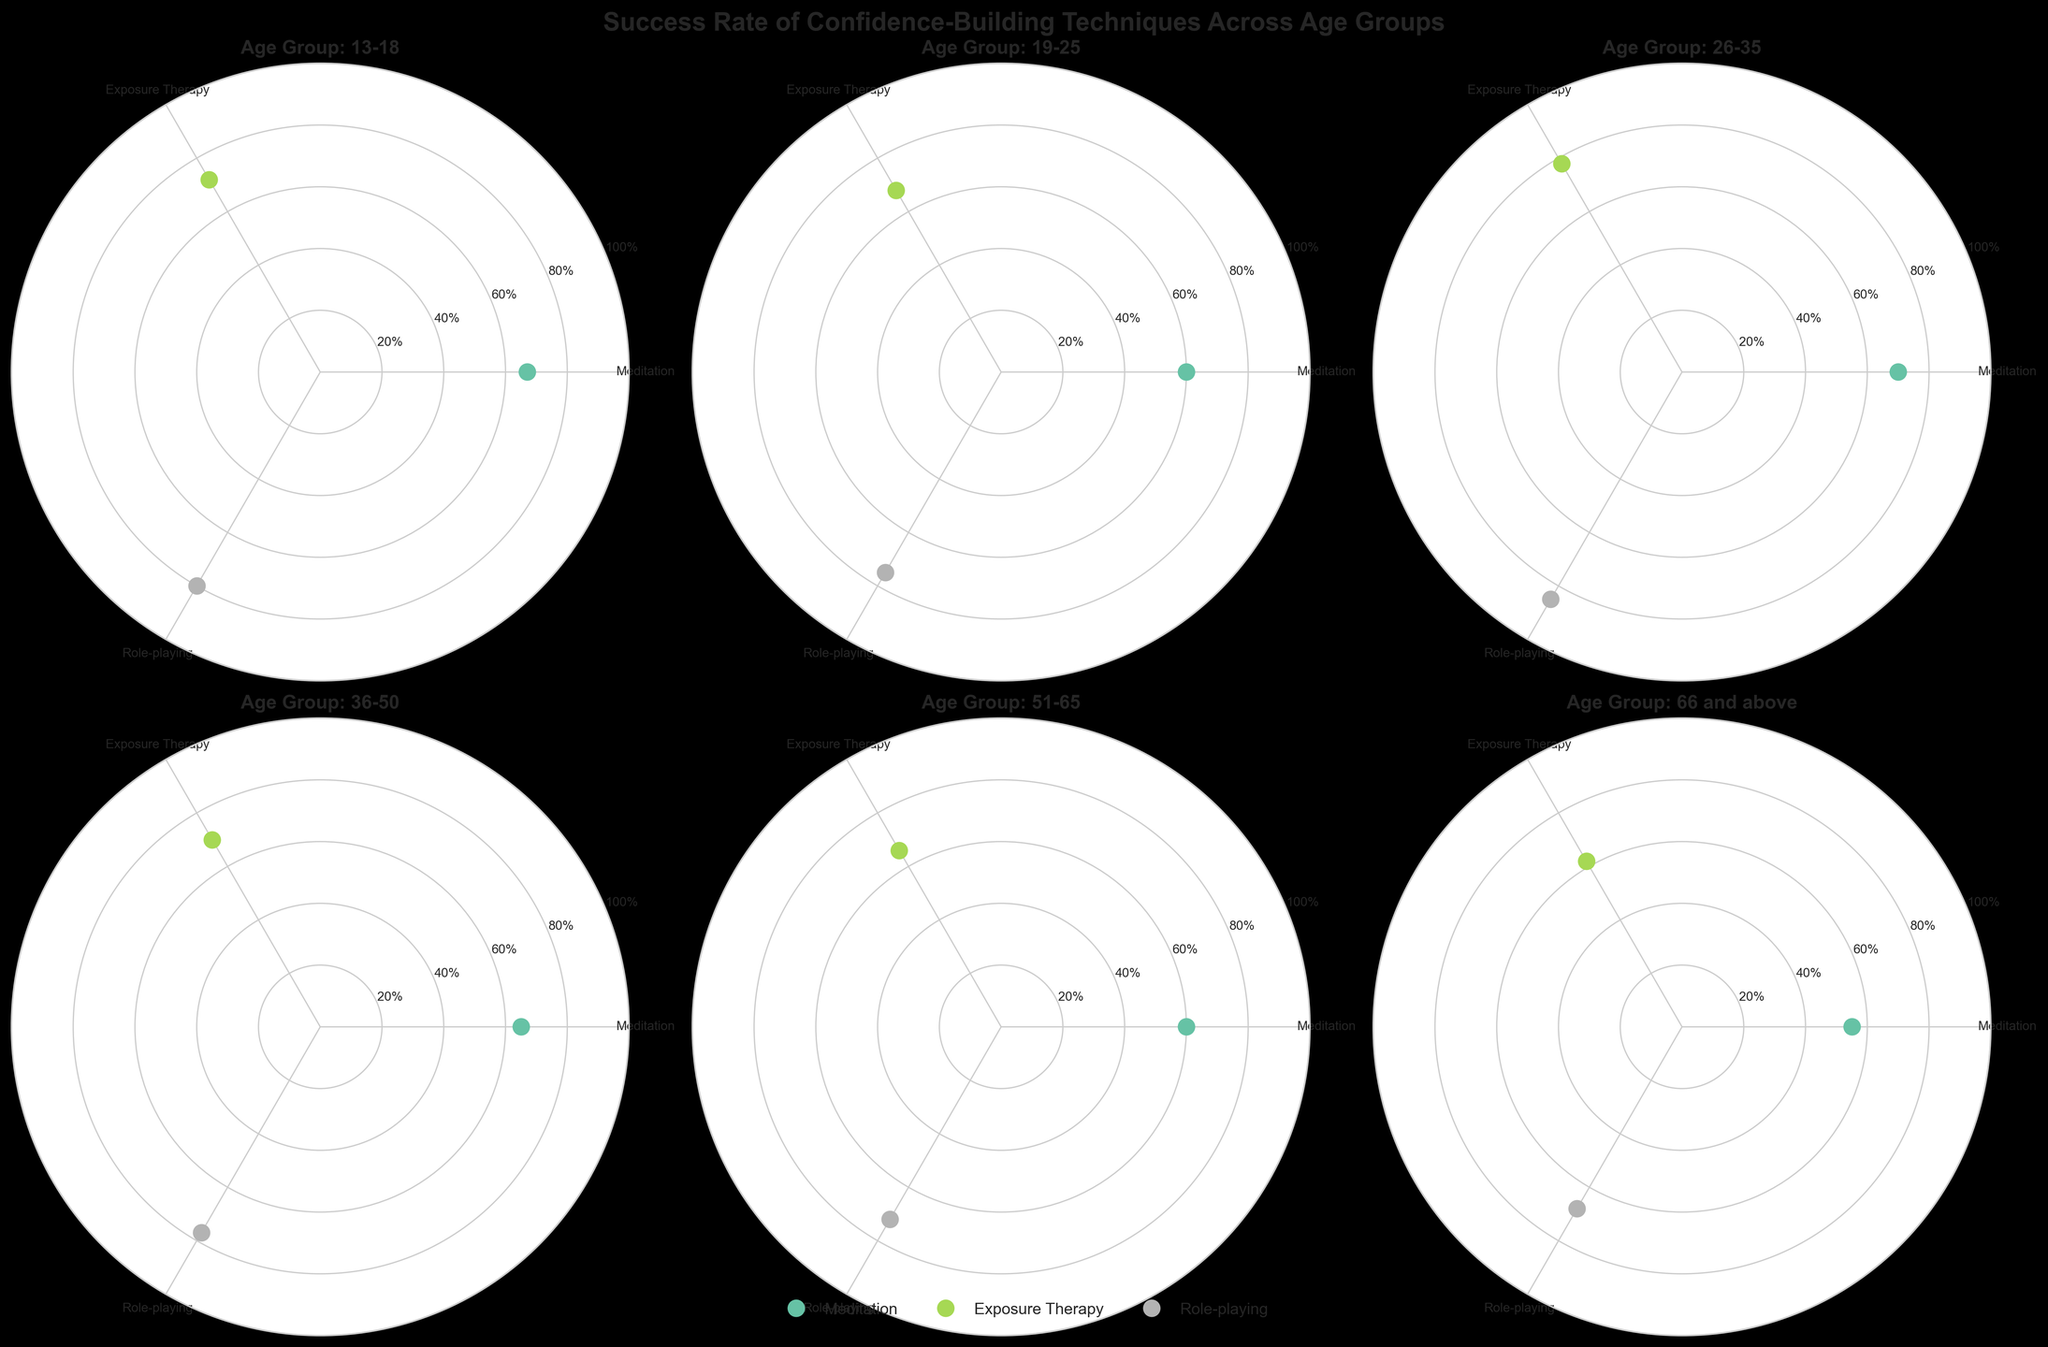What is the title of the figure? The title is written at the top center of the overall figure, summarizing the main focus of the plot's content.
Answer: "Success Rate of Confidence-Building Techniques Across Age Groups" What colors represent the different techniques? Each technique is represented by a distinct color in the polar chart subplots. The colors are labeled in the legend.
Answer: Different colors from the Set2 colormap Which age group has the highest success rate for meditation? Look for the age group whose marker is at the highest position radially for meditation. This is visible in the polar subplot for that age group.
Answer: 26-35 Compare the success rates for role-playing between the age groups 13-18 and 66 and above. Which is higher? Check the radial position of the markers for role-playing in both age groups' polar subplots.
Answer: 13-18 What is the trend of exposure therapy success rates across the age groups? Observe the radial positions of the exposure therapy markers in each subplot to discern the trend. Note that the order of subplots follows ascending age groups.
Answer: The success rate generally decreases with age What is the average success rate of role-playing across all age groups? Sum the success rates of role-playing for all age groups and divide by the number of age groups.
Answer: (80 + 75 + 85 + 77 + 72 + 68) / 6 = 75.17 In which age group does meditation have a lower success rate than exposure therapy but higher than role-playing? Look for the polar subplot where the meditation marker is between the exposure therapy and role-playing markers radially.
Answer: None How does the success rate of exposure therapy for 19-25 compare to meditation in the same age group? Observe the positions of the exposure therapy and meditation markers in the 19-25 polar subplot and compare the radial distances.
Answer: Exposure therapy is higher Which technique has the least variation in success rates across all age groups? Compare the spread of the markers for each technique across all subplots to find which has the smallest range.
Answer: Meditation 